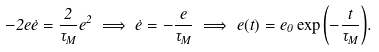Convert formula to latex. <formula><loc_0><loc_0><loc_500><loc_500>- 2 e \dot { e } = \frac { 2 } { \tau _ { M } } e ^ { 2 } \implies \dot { e } = - \frac { e } { \tau _ { M } } \implies e ( t ) = e _ { 0 } \exp { \left ( - \frac { t } { \tau _ { M } } \right ) } .</formula> 